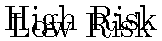In the context of developing a scalable Scala-based trading platform, consider the polynomial surface representation of risk assessment for multiple asset correlations shown above. What does the peak in the surface signify, and how might this information be utilized in the trading platform's risk management system? To understand the significance of the polynomial surface representation and its application in a Scala-based trading platform, let's break down the key elements:

1. Surface Interpretation:
   - The x and y axes represent two different assets (Asset A and Asset B).
   - The z-axis represents the risk level.
   - The colors on the surface indicate risk levels, with warmer colors (red/yellow) showing higher risk and cooler colors (blue/green) showing lower risk.

2. Peak Significance:
   - The peak in the surface (red area) indicates a point of maximum risk.
   - This occurs when both Asset A and Asset B are at specific values (around 1 on both axes).
   - It suggests a strong positive correlation between the two assets at these points, leading to increased overall portfolio risk.

3. Application in Scala-based Trading Platform:
   - Risk Quantification: The platform can use similar polynomial surfaces to quantify risk across multiple asset pairs.
   - Real-time Monitoring: Implement Scala functions to continuously update these risk surfaces based on market data.
   - Correlation Analysis: Use the surface to identify high-correlation scenarios between assets.
   - Risk Alerts: Set up triggers in the platform to alert traders when asset combinations approach high-risk areas on the surface.
   - Portfolio Optimization: Utilize the risk surface data to suggest optimal asset allocations that minimize overall portfolio risk.
   - Stress Testing: Simulate various market scenarios by manipulating the surface and observing the impact on risk levels.

4. Implementation Considerations:
   - Scala's functional programming features can be leveraged to efficiently compute and update these risk surfaces.
   - Use parallel processing capabilities in Scala to handle calculations for multiple asset pairs simultaneously.
   - Implement caching mechanisms to store and quickly retrieve commonly accessed risk data.

5. Integration with Trading Strategies:
   - Develop trading algorithms that incorporate the risk surface data to make more informed decisions.
   - Use the risk assessment to dynamically adjust position sizes and hedging strategies.

By incorporating this polynomial surface representation of risk into the Scala-based trading platform, the financial institution can enhance its risk management capabilities, leading to more informed trading decisions and better overall portfolio management.
Answer: The peak signifies maximum risk due to high asset correlation, used for real-time risk monitoring and portfolio optimization in the trading platform. 